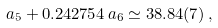Convert formula to latex. <formula><loc_0><loc_0><loc_500><loc_500>a _ { 5 } + 0 . 2 4 2 7 5 4 \, a _ { 6 } \simeq 3 8 . 8 4 ( 7 ) \, ,</formula> 